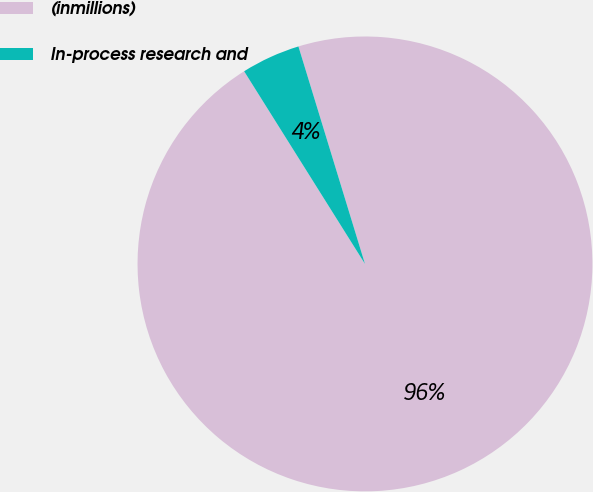Convert chart to OTSL. <chart><loc_0><loc_0><loc_500><loc_500><pie_chart><fcel>(inmillions)<fcel>In-process research and<nl><fcel>95.81%<fcel>4.19%<nl></chart> 